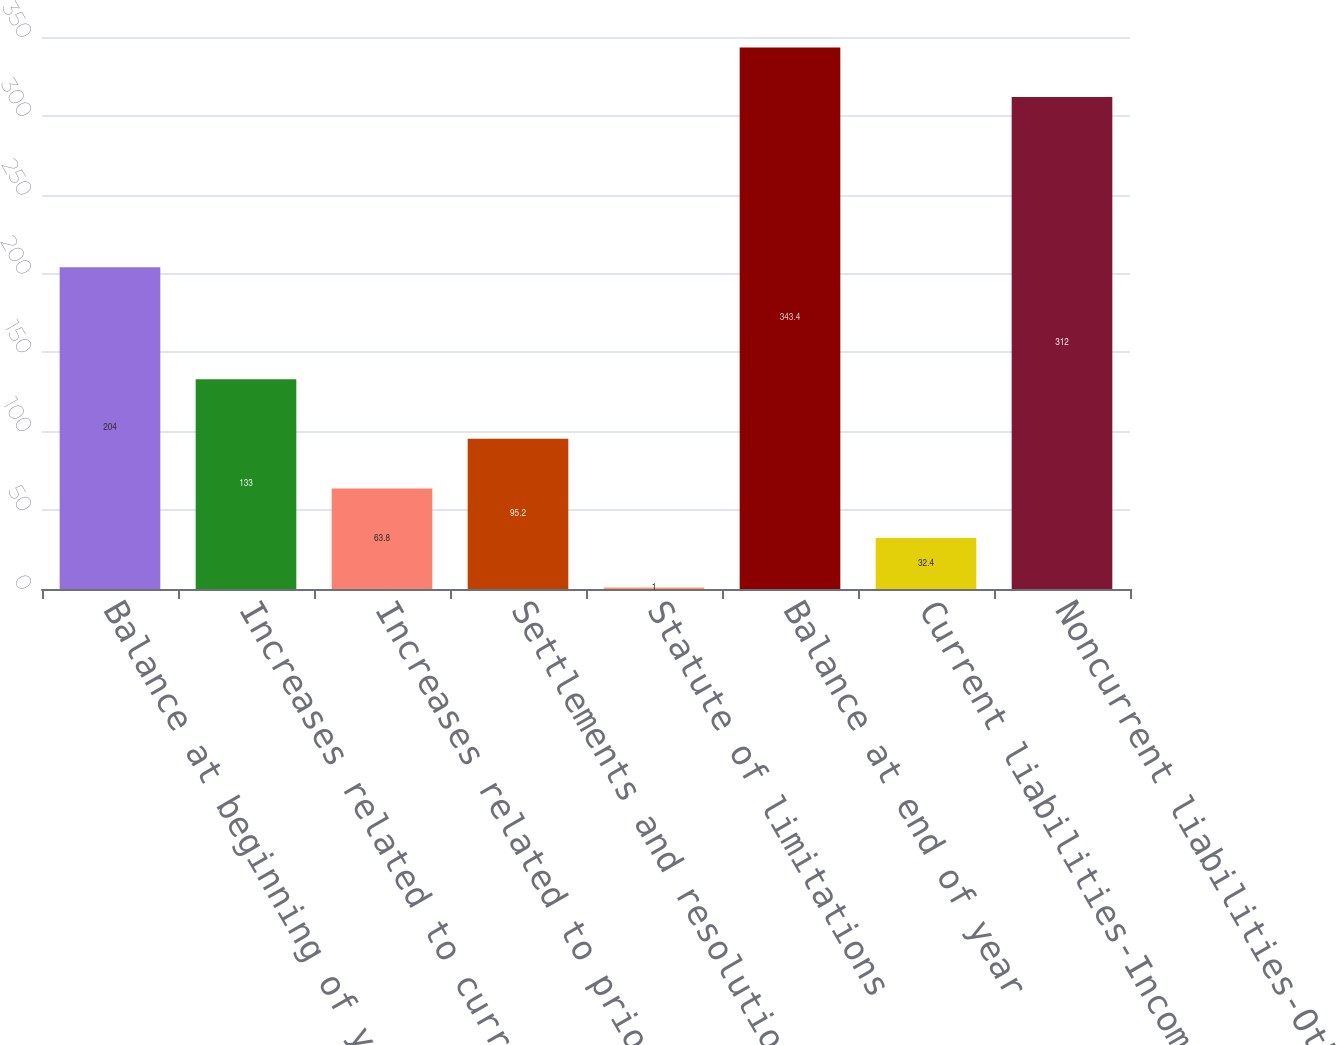Convert chart to OTSL. <chart><loc_0><loc_0><loc_500><loc_500><bar_chart><fcel>Balance at beginning of year<fcel>Increases related to current<fcel>Increases related to prior<fcel>Settlements and resolutions of<fcel>Statute of limitations<fcel>Balance at end of year<fcel>Current liabilities-Income<fcel>Noncurrent liabilities-Other<nl><fcel>204<fcel>133<fcel>63.8<fcel>95.2<fcel>1<fcel>343.4<fcel>32.4<fcel>312<nl></chart> 